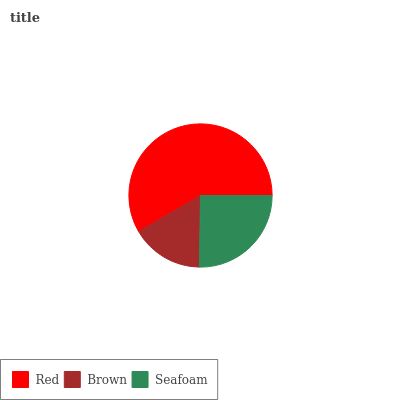Is Brown the minimum?
Answer yes or no. Yes. Is Red the maximum?
Answer yes or no. Yes. Is Seafoam the minimum?
Answer yes or no. No. Is Seafoam the maximum?
Answer yes or no. No. Is Seafoam greater than Brown?
Answer yes or no. Yes. Is Brown less than Seafoam?
Answer yes or no. Yes. Is Brown greater than Seafoam?
Answer yes or no. No. Is Seafoam less than Brown?
Answer yes or no. No. Is Seafoam the high median?
Answer yes or no. Yes. Is Seafoam the low median?
Answer yes or no. Yes. Is Red the high median?
Answer yes or no. No. Is Brown the low median?
Answer yes or no. No. 